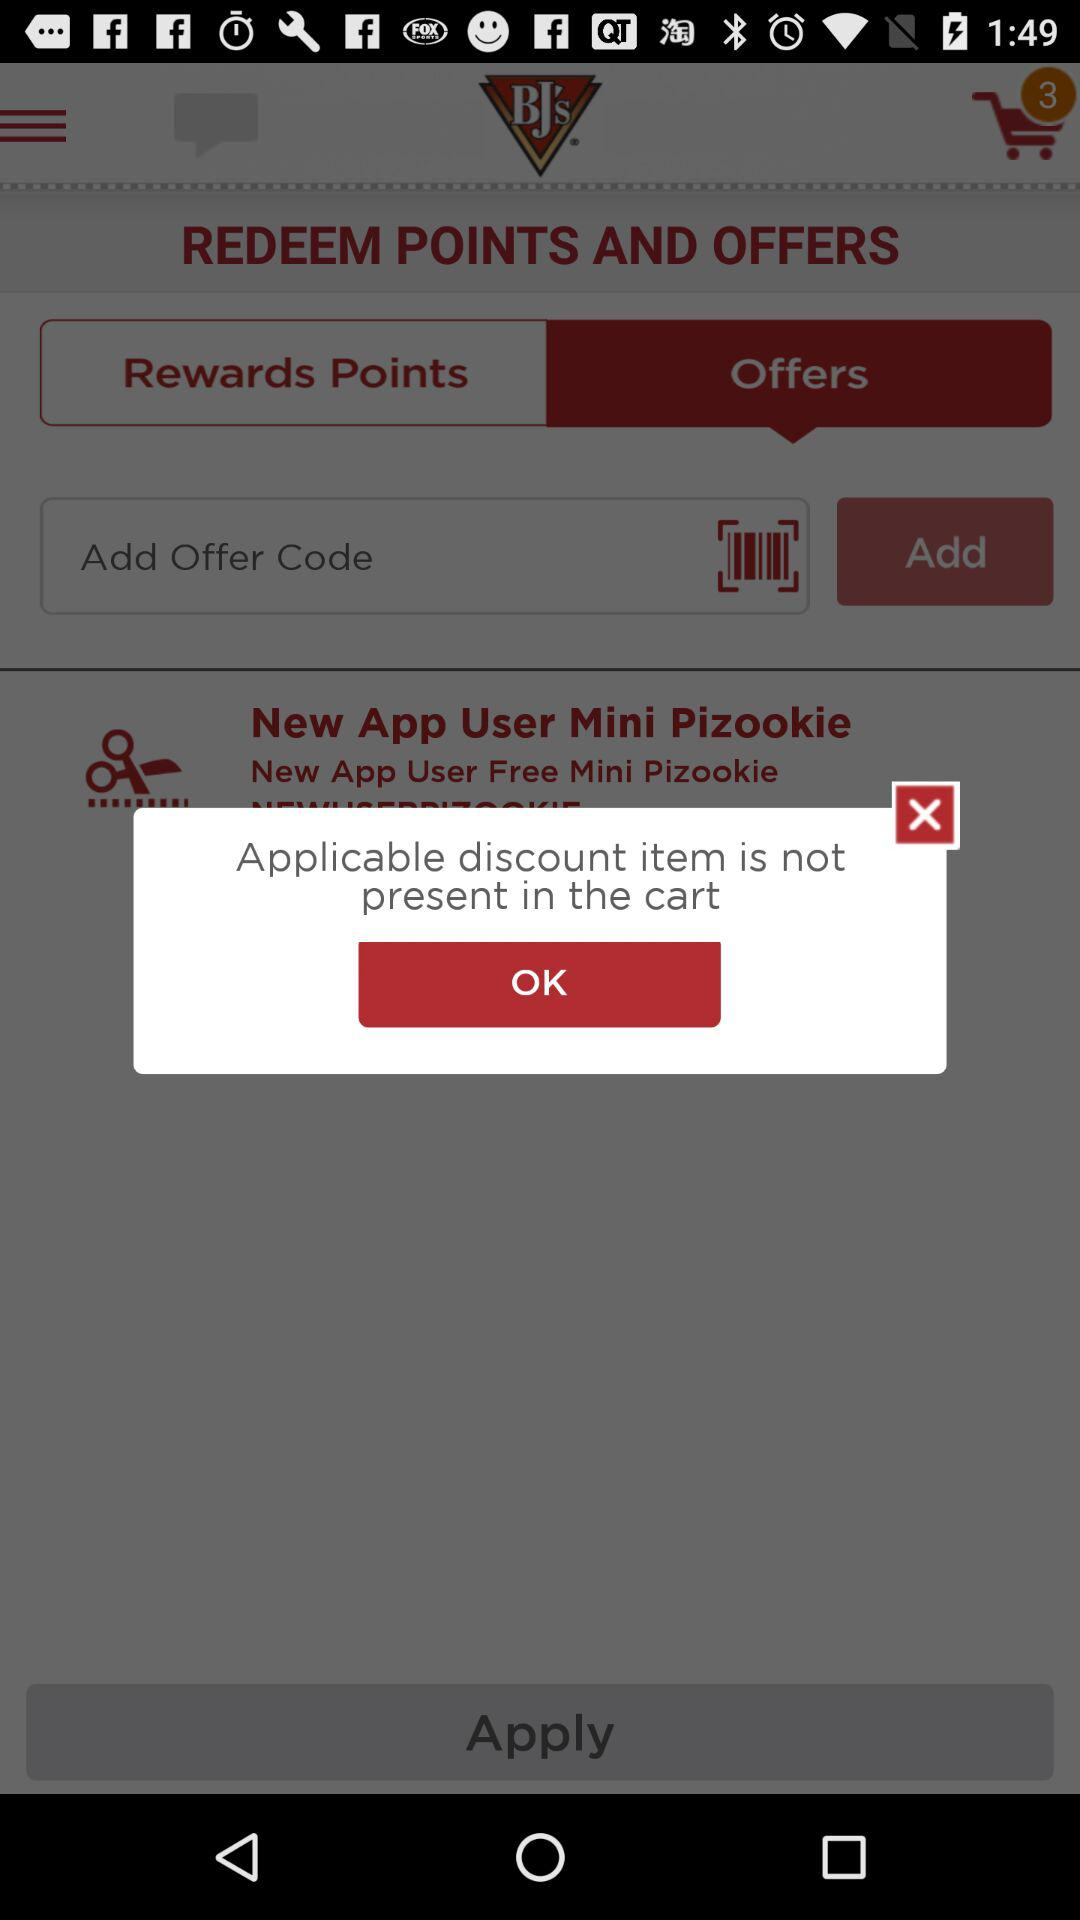What is the entered offer code?
When the provided information is insufficient, respond with <no answer>. <no answer> 